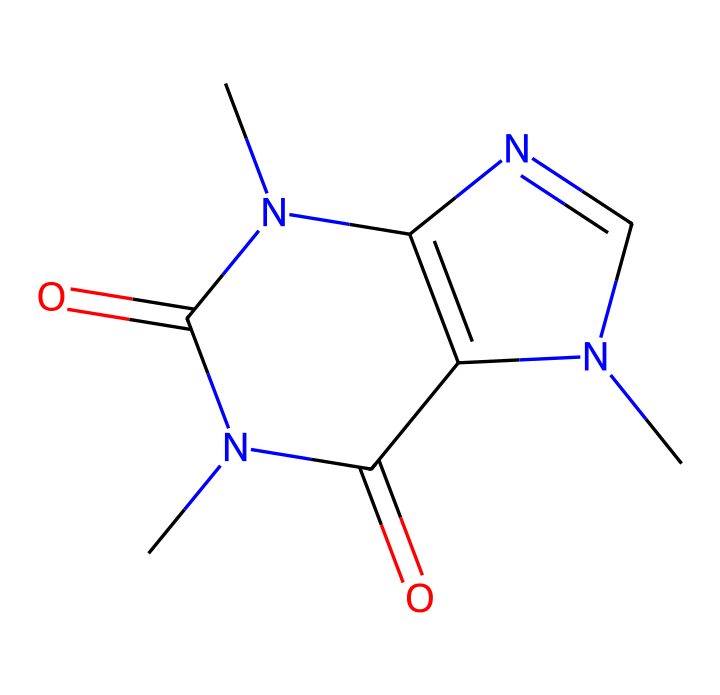What is the molecular formula of caffeine? By analyzing the SMILES representation, we note the presence of carbon (C), hydrogen (H), nitrogen (N), and oxygen (O) atoms. Counting the atoms, we find there are 8 carbons, 10 hydrogens, 4 nitrogens, and 2 oxygens. Thus, the molecular formula is C8H10N4O2.
Answer: C8H10N4O2 How many nitrogen atoms are present in caffeine? The SMILES representation shows four nitrogen atoms (N). Counting the N symbols in the structure gives us the answer directly.
Answer: 4 What type of structure does caffeine have? The structure identified in the SMILES representation indicates that caffeine is a cyclic compound due to the presence of rings in the structure. This can be observed from the numbers 1 and 2 indicating bond connections forming rings.
Answer: cyclic What is the total number of rings present in the structure of caffeine? In the SMILES notation, numbers 1 and 2 indicate two interconnected rings. Counting these numbers gives a total of two rings formed in the structure.
Answer: 2 What functional groups are present in caffeine? Analyzing the structure, we see carbonyl groups (C=O) represented in the structure. The presence of these specific bonds indicates functional groups present in this molecule, specifically imines and amides due to the nitrogen connectivity.
Answer: carbonyl groups Which atoms serve as the backbone of caffeine's structure? The backbone of caffeine primarily consists of carbon atoms. In the chemical structure, the carbon atoms hold up the majority of the structure and connect to the nitrogen and oxygen atoms. This reflects a typical feature of organic compounds relying on carbon framework.
Answer: carbon atoms What characteristic primarily classifies caffeine as a stimulant? Caffeine possesses a unique nitrogen arrangement allowing it to interact with adenosine receptors in the brain, which contributes to its stimulant effect. Observing the nitrogen functionality reinforces this classification as it relates to its biological activity.
Answer: nitrogen arrangement 